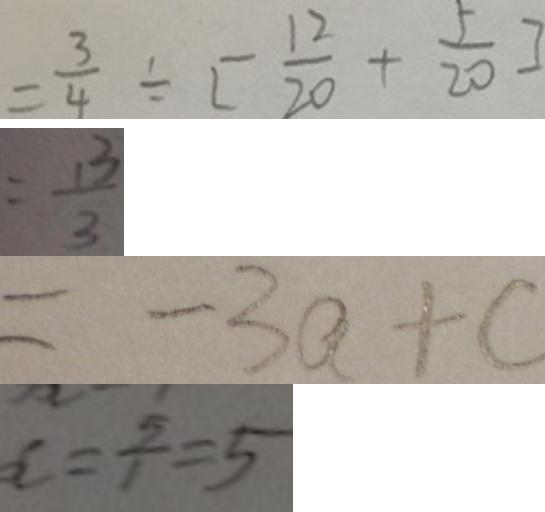<formula> <loc_0><loc_0><loc_500><loc_500>= \frac { 3 } { 4 } \div [ \frac { 1 2 } { 2 0 } + \frac { 5 } { 2 0 } ] 
 = \frac { 1 3 } { 3 } 
 = - 3 a + c 
 x = \frac { 5 } { 1 } = 5</formula> 